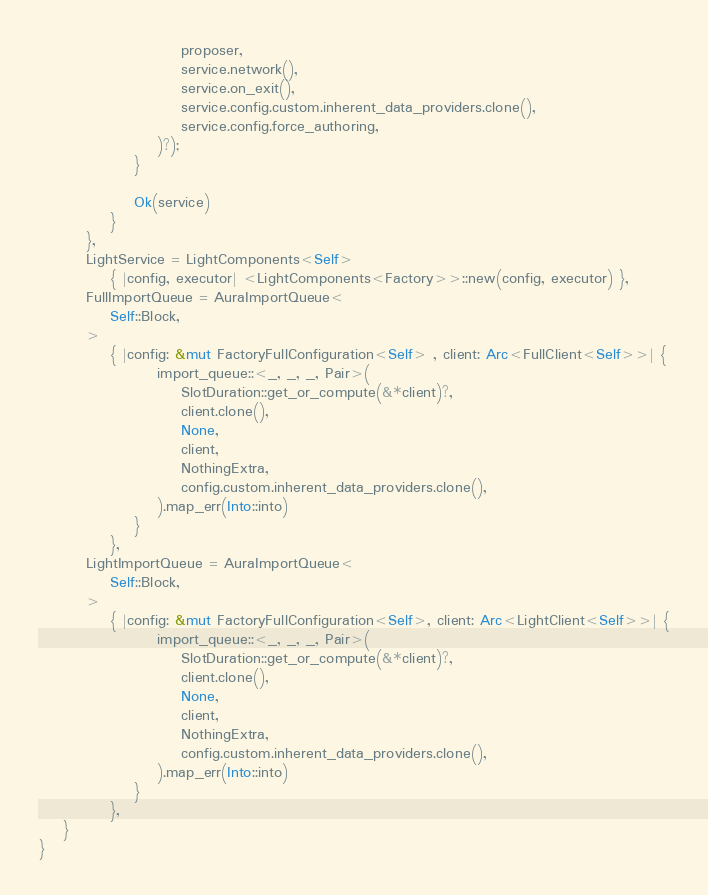Convert code to text. <code><loc_0><loc_0><loc_500><loc_500><_Rust_>						proposer,
						service.network(),
						service.on_exit(),
						service.config.custom.inherent_data_providers.clone(),
						service.config.force_authoring,
					)?);
				}

				Ok(service)
			}
		},
		LightService = LightComponents<Self>
			{ |config, executor| <LightComponents<Factory>>::new(config, executor) },
		FullImportQueue = AuraImportQueue<
			Self::Block,
		>
			{ |config: &mut FactoryFullConfiguration<Self> , client: Arc<FullClient<Self>>| {
					import_queue::<_, _, _, Pair>(
						SlotDuration::get_or_compute(&*client)?,
						client.clone(),
						None,
						client,
						NothingExtra,
						config.custom.inherent_data_providers.clone(),
					).map_err(Into::into)
				}
			},
		LightImportQueue = AuraImportQueue<
			Self::Block,
		>
			{ |config: &mut FactoryFullConfiguration<Self>, client: Arc<LightClient<Self>>| {
					import_queue::<_, _, _, Pair>(
						SlotDuration::get_or_compute(&*client)?,
						client.clone(),
						None,
						client,
						NothingExtra,
						config.custom.inherent_data_providers.clone(),
					).map_err(Into::into)
				}
			},
	}
}
</code> 